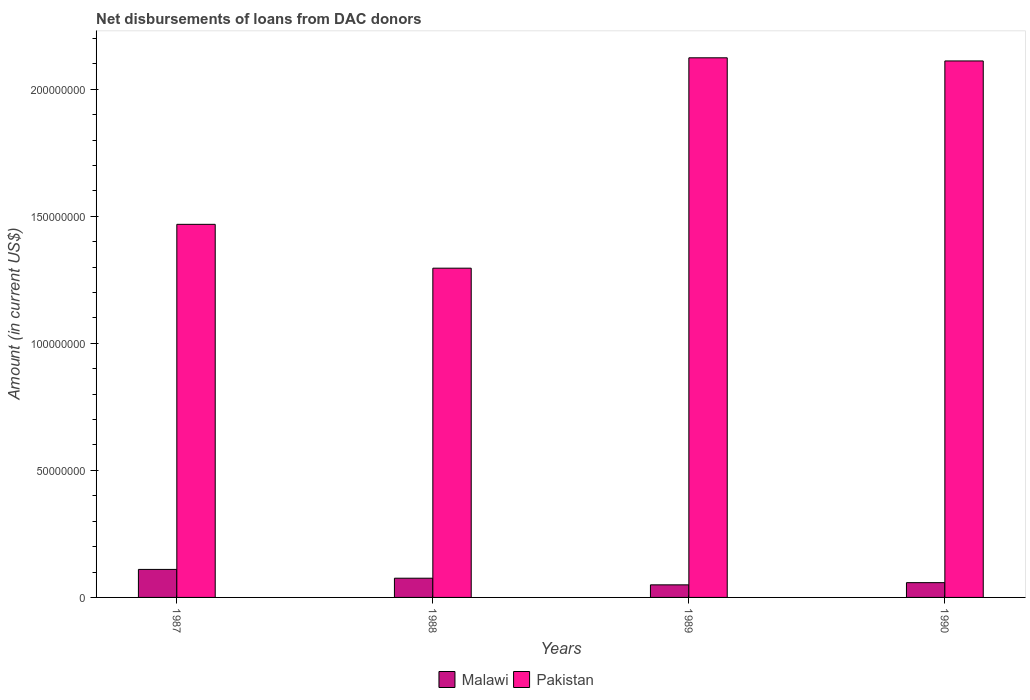How many different coloured bars are there?
Ensure brevity in your answer.  2. How many groups of bars are there?
Provide a succinct answer. 4. Are the number of bars on each tick of the X-axis equal?
Provide a short and direct response. Yes. How many bars are there on the 2nd tick from the left?
Give a very brief answer. 2. What is the label of the 1st group of bars from the left?
Provide a short and direct response. 1987. What is the amount of loans disbursed in Pakistan in 1989?
Offer a very short reply. 2.12e+08. Across all years, what is the maximum amount of loans disbursed in Pakistan?
Your answer should be very brief. 2.12e+08. Across all years, what is the minimum amount of loans disbursed in Malawi?
Ensure brevity in your answer.  4.95e+06. What is the total amount of loans disbursed in Pakistan in the graph?
Give a very brief answer. 7.00e+08. What is the difference between the amount of loans disbursed in Pakistan in 1987 and that in 1990?
Ensure brevity in your answer.  -6.43e+07. What is the difference between the amount of loans disbursed in Malawi in 1987 and the amount of loans disbursed in Pakistan in 1989?
Offer a terse response. -2.01e+08. What is the average amount of loans disbursed in Malawi per year?
Give a very brief answer. 7.34e+06. In the year 1989, what is the difference between the amount of loans disbursed in Pakistan and amount of loans disbursed in Malawi?
Your answer should be compact. 2.07e+08. What is the ratio of the amount of loans disbursed in Malawi in 1987 to that in 1988?
Provide a succinct answer. 1.46. Is the amount of loans disbursed in Malawi in 1988 less than that in 1989?
Your answer should be compact. No. Is the difference between the amount of loans disbursed in Pakistan in 1988 and 1990 greater than the difference between the amount of loans disbursed in Malawi in 1988 and 1990?
Provide a short and direct response. No. What is the difference between the highest and the second highest amount of loans disbursed in Pakistan?
Your response must be concise. 1.24e+06. What is the difference between the highest and the lowest amount of loans disbursed in Malawi?
Offer a terse response. 6.08e+06. In how many years, is the amount of loans disbursed in Malawi greater than the average amount of loans disbursed in Malawi taken over all years?
Your answer should be very brief. 2. What does the 1st bar from the left in 1987 represents?
Offer a terse response. Malawi. What does the 2nd bar from the right in 1989 represents?
Offer a terse response. Malawi. How many bars are there?
Provide a short and direct response. 8. Are all the bars in the graph horizontal?
Ensure brevity in your answer.  No. How many years are there in the graph?
Offer a terse response. 4. What is the difference between two consecutive major ticks on the Y-axis?
Keep it short and to the point. 5.00e+07. Does the graph contain any zero values?
Your answer should be compact. No. Where does the legend appear in the graph?
Provide a succinct answer. Bottom center. How are the legend labels stacked?
Keep it short and to the point. Horizontal. What is the title of the graph?
Offer a terse response. Net disbursements of loans from DAC donors. What is the label or title of the Y-axis?
Provide a succinct answer. Amount (in current US$). What is the Amount (in current US$) of Malawi in 1987?
Offer a terse response. 1.10e+07. What is the Amount (in current US$) of Pakistan in 1987?
Provide a succinct answer. 1.47e+08. What is the Amount (in current US$) of Malawi in 1988?
Keep it short and to the point. 7.56e+06. What is the Amount (in current US$) of Pakistan in 1988?
Keep it short and to the point. 1.30e+08. What is the Amount (in current US$) in Malawi in 1989?
Keep it short and to the point. 4.95e+06. What is the Amount (in current US$) of Pakistan in 1989?
Keep it short and to the point. 2.12e+08. What is the Amount (in current US$) of Malawi in 1990?
Your answer should be very brief. 5.82e+06. What is the Amount (in current US$) of Pakistan in 1990?
Ensure brevity in your answer.  2.11e+08. Across all years, what is the maximum Amount (in current US$) in Malawi?
Make the answer very short. 1.10e+07. Across all years, what is the maximum Amount (in current US$) of Pakistan?
Provide a succinct answer. 2.12e+08. Across all years, what is the minimum Amount (in current US$) of Malawi?
Your answer should be compact. 4.95e+06. Across all years, what is the minimum Amount (in current US$) in Pakistan?
Keep it short and to the point. 1.30e+08. What is the total Amount (in current US$) in Malawi in the graph?
Keep it short and to the point. 2.94e+07. What is the total Amount (in current US$) in Pakistan in the graph?
Give a very brief answer. 7.00e+08. What is the difference between the Amount (in current US$) in Malawi in 1987 and that in 1988?
Provide a short and direct response. 3.47e+06. What is the difference between the Amount (in current US$) of Pakistan in 1987 and that in 1988?
Offer a very short reply. 1.73e+07. What is the difference between the Amount (in current US$) of Malawi in 1987 and that in 1989?
Make the answer very short. 6.08e+06. What is the difference between the Amount (in current US$) of Pakistan in 1987 and that in 1989?
Give a very brief answer. -6.55e+07. What is the difference between the Amount (in current US$) of Malawi in 1987 and that in 1990?
Offer a very short reply. 5.21e+06. What is the difference between the Amount (in current US$) in Pakistan in 1987 and that in 1990?
Provide a short and direct response. -6.43e+07. What is the difference between the Amount (in current US$) in Malawi in 1988 and that in 1989?
Ensure brevity in your answer.  2.61e+06. What is the difference between the Amount (in current US$) of Pakistan in 1988 and that in 1989?
Provide a succinct answer. -8.28e+07. What is the difference between the Amount (in current US$) of Malawi in 1988 and that in 1990?
Ensure brevity in your answer.  1.74e+06. What is the difference between the Amount (in current US$) of Pakistan in 1988 and that in 1990?
Make the answer very short. -8.16e+07. What is the difference between the Amount (in current US$) in Malawi in 1989 and that in 1990?
Keep it short and to the point. -8.68e+05. What is the difference between the Amount (in current US$) of Pakistan in 1989 and that in 1990?
Make the answer very short. 1.24e+06. What is the difference between the Amount (in current US$) of Malawi in 1987 and the Amount (in current US$) of Pakistan in 1988?
Your response must be concise. -1.19e+08. What is the difference between the Amount (in current US$) in Malawi in 1987 and the Amount (in current US$) in Pakistan in 1989?
Ensure brevity in your answer.  -2.01e+08. What is the difference between the Amount (in current US$) in Malawi in 1987 and the Amount (in current US$) in Pakistan in 1990?
Offer a terse response. -2.00e+08. What is the difference between the Amount (in current US$) in Malawi in 1988 and the Amount (in current US$) in Pakistan in 1989?
Ensure brevity in your answer.  -2.05e+08. What is the difference between the Amount (in current US$) in Malawi in 1988 and the Amount (in current US$) in Pakistan in 1990?
Provide a short and direct response. -2.04e+08. What is the difference between the Amount (in current US$) of Malawi in 1989 and the Amount (in current US$) of Pakistan in 1990?
Your answer should be compact. -2.06e+08. What is the average Amount (in current US$) in Malawi per year?
Ensure brevity in your answer.  7.34e+06. What is the average Amount (in current US$) in Pakistan per year?
Your answer should be compact. 1.75e+08. In the year 1987, what is the difference between the Amount (in current US$) of Malawi and Amount (in current US$) of Pakistan?
Provide a succinct answer. -1.36e+08. In the year 1988, what is the difference between the Amount (in current US$) in Malawi and Amount (in current US$) in Pakistan?
Ensure brevity in your answer.  -1.22e+08. In the year 1989, what is the difference between the Amount (in current US$) in Malawi and Amount (in current US$) in Pakistan?
Your answer should be compact. -2.07e+08. In the year 1990, what is the difference between the Amount (in current US$) in Malawi and Amount (in current US$) in Pakistan?
Offer a very short reply. -2.05e+08. What is the ratio of the Amount (in current US$) in Malawi in 1987 to that in 1988?
Your answer should be compact. 1.46. What is the ratio of the Amount (in current US$) in Pakistan in 1987 to that in 1988?
Your answer should be compact. 1.13. What is the ratio of the Amount (in current US$) in Malawi in 1987 to that in 1989?
Provide a short and direct response. 2.23. What is the ratio of the Amount (in current US$) of Pakistan in 1987 to that in 1989?
Your response must be concise. 0.69. What is the ratio of the Amount (in current US$) of Malawi in 1987 to that in 1990?
Ensure brevity in your answer.  1.9. What is the ratio of the Amount (in current US$) of Pakistan in 1987 to that in 1990?
Keep it short and to the point. 0.7. What is the ratio of the Amount (in current US$) in Malawi in 1988 to that in 1989?
Your answer should be compact. 1.53. What is the ratio of the Amount (in current US$) of Pakistan in 1988 to that in 1989?
Provide a short and direct response. 0.61. What is the ratio of the Amount (in current US$) in Malawi in 1988 to that in 1990?
Offer a terse response. 1.3. What is the ratio of the Amount (in current US$) of Pakistan in 1988 to that in 1990?
Your response must be concise. 0.61. What is the ratio of the Amount (in current US$) of Malawi in 1989 to that in 1990?
Offer a terse response. 0.85. What is the ratio of the Amount (in current US$) of Pakistan in 1989 to that in 1990?
Give a very brief answer. 1.01. What is the difference between the highest and the second highest Amount (in current US$) in Malawi?
Give a very brief answer. 3.47e+06. What is the difference between the highest and the second highest Amount (in current US$) of Pakistan?
Offer a terse response. 1.24e+06. What is the difference between the highest and the lowest Amount (in current US$) in Malawi?
Your answer should be compact. 6.08e+06. What is the difference between the highest and the lowest Amount (in current US$) in Pakistan?
Your response must be concise. 8.28e+07. 